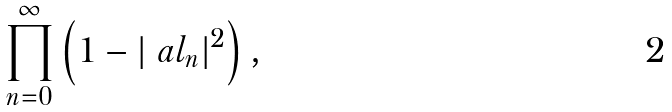Convert formula to latex. <formula><loc_0><loc_0><loc_500><loc_500>\prod _ { n = 0 } ^ { \infty } \left ( 1 - | \ a l _ { n } | ^ { 2 } \right ) ,</formula> 